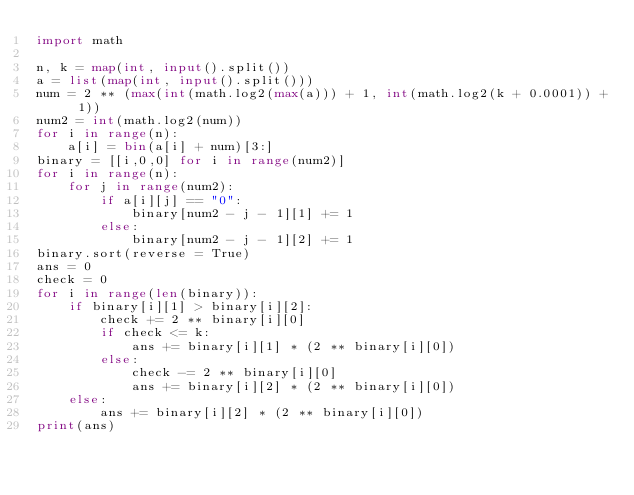<code> <loc_0><loc_0><loc_500><loc_500><_Python_>import math

n, k = map(int, input().split())
a = list(map(int, input().split()))
num = 2 ** (max(int(math.log2(max(a))) + 1, int(math.log2(k + 0.0001)) + 1))
num2 = int(math.log2(num))
for i in range(n):
    a[i] = bin(a[i] + num)[3:]
binary = [[i,0,0] for i in range(num2)]
for i in range(n):
    for j in range(num2):
        if a[i][j] == "0":
            binary[num2 - j - 1][1] += 1
        else:
            binary[num2 - j - 1][2] += 1
binary.sort(reverse = True)
ans = 0
check = 0
for i in range(len(binary)):
    if binary[i][1] > binary[i][2]:
        check += 2 ** binary[i][0]
        if check <= k:
            ans += binary[i][1] * (2 ** binary[i][0])
        else:
            check -= 2 ** binary[i][0]
            ans += binary[i][2] * (2 ** binary[i][0])
    else:
        ans += binary[i][2] * (2 ** binary[i][0])
print(ans)</code> 